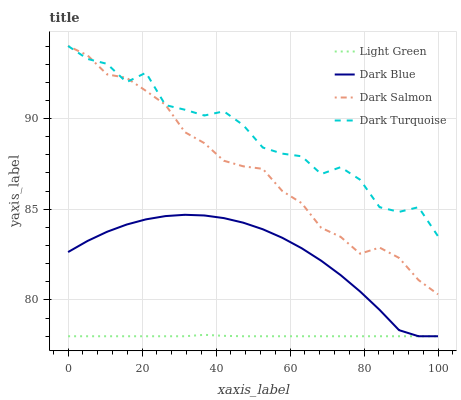Does Light Green have the minimum area under the curve?
Answer yes or no. Yes. Does Dark Turquoise have the maximum area under the curve?
Answer yes or no. Yes. Does Dark Salmon have the minimum area under the curve?
Answer yes or no. No. Does Dark Salmon have the maximum area under the curve?
Answer yes or no. No. Is Light Green the smoothest?
Answer yes or no. Yes. Is Dark Turquoise the roughest?
Answer yes or no. Yes. Is Dark Salmon the smoothest?
Answer yes or no. No. Is Dark Salmon the roughest?
Answer yes or no. No. Does Dark Blue have the lowest value?
Answer yes or no. Yes. Does Dark Salmon have the lowest value?
Answer yes or no. No. Does Dark Turquoise have the highest value?
Answer yes or no. Yes. Does Light Green have the highest value?
Answer yes or no. No. Is Dark Blue less than Dark Turquoise?
Answer yes or no. Yes. Is Dark Turquoise greater than Dark Blue?
Answer yes or no. Yes. Does Light Green intersect Dark Blue?
Answer yes or no. Yes. Is Light Green less than Dark Blue?
Answer yes or no. No. Is Light Green greater than Dark Blue?
Answer yes or no. No. Does Dark Blue intersect Dark Turquoise?
Answer yes or no. No. 